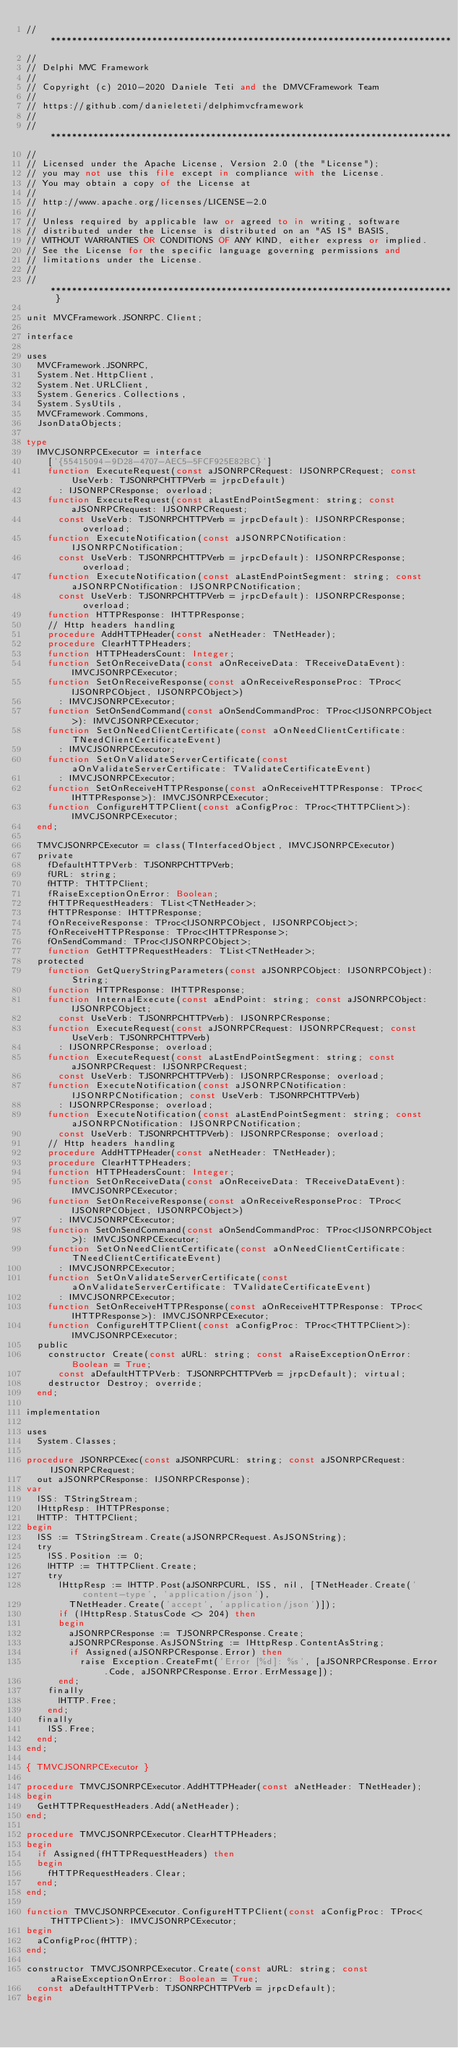Convert code to text. <code><loc_0><loc_0><loc_500><loc_500><_Pascal_>// ***************************************************************************
//
// Delphi MVC Framework
//
// Copyright (c) 2010-2020 Daniele Teti and the DMVCFramework Team
//
// https://github.com/danieleteti/delphimvcframework
//
// ***************************************************************************
//
// Licensed under the Apache License, Version 2.0 (the "License");
// you may not use this file except in compliance with the License.
// You may obtain a copy of the License at
//
// http://www.apache.org/licenses/LICENSE-2.0
//
// Unless required by applicable law or agreed to in writing, software
// distributed under the License is distributed on an "AS IS" BASIS,
// WITHOUT WARRANTIES OR CONDITIONS OF ANY KIND, either express or implied.
// See the License for the specific language governing permissions and
// limitations under the License.
//
// *************************************************************************** }

unit MVCFramework.JSONRPC.Client;

interface

uses
  MVCFramework.JSONRPC,
  System.Net.HttpClient,
  System.Net.URLClient,
  System.Generics.Collections,
  System.SysUtils,
  MVCFramework.Commons,
  JsonDataObjects;

type
  IMVCJSONRPCExecutor = interface
    ['{55415094-9D28-4707-AEC5-5FCF925E82BC}']
    function ExecuteRequest(const aJSONRPCRequest: IJSONRPCRequest; const UseVerb: TJSONRPCHTTPVerb = jrpcDefault)
      : IJSONRPCResponse; overload;
    function ExecuteRequest(const aLastEndPointSegment: string; const aJSONRPCRequest: IJSONRPCRequest;
      const UseVerb: TJSONRPCHTTPVerb = jrpcDefault): IJSONRPCResponse; overload;
    function ExecuteNotification(const aJSONRPCNotification: IJSONRPCNotification;
      const UseVerb: TJSONRPCHTTPVerb = jrpcDefault): IJSONRPCResponse; overload;
    function ExecuteNotification(const aLastEndPointSegment: string; const aJSONRPCNotification: IJSONRPCNotification;
      const UseVerb: TJSONRPCHTTPVerb = jrpcDefault): IJSONRPCResponse; overload;
    function HTTPResponse: IHTTPResponse;
    // Http headers handling
    procedure AddHTTPHeader(const aNetHeader: TNetHeader);
    procedure ClearHTTPHeaders;
    function HTTPHeadersCount: Integer;
    function SetOnReceiveData(const aOnReceiveData: TReceiveDataEvent): IMVCJSONRPCExecutor;
    function SetOnReceiveResponse(const aOnReceiveResponseProc: TProc<IJSONRPCObject, IJSONRPCObject>)
      : IMVCJSONRPCExecutor;
    function SetOnSendCommand(const aOnSendCommandProc: TProc<IJSONRPCObject>): IMVCJSONRPCExecutor;
    function SetOnNeedClientCertificate(const aOnNeedClientCertificate: TNeedClientCertificateEvent)
      : IMVCJSONRPCExecutor;
    function SetOnValidateServerCertificate(const aOnValidateServerCertificate: TValidateCertificateEvent)
      : IMVCJSONRPCExecutor;
    function SetOnReceiveHTTPResponse(const aOnReceiveHTTPResponse: TProc<IHTTPResponse>): IMVCJSONRPCExecutor;
    function ConfigureHTTPClient(const aConfigProc: TProc<THTTPClient>): IMVCJSONRPCExecutor;
  end;

  TMVCJSONRPCExecutor = class(TInterfacedObject, IMVCJSONRPCExecutor)
  private
    fDefaultHTTPVerb: TJSONRPCHTTPVerb;
    fURL: string;
    fHTTP: THTTPClient;
    fRaiseExceptionOnError: Boolean;
    fHTTPRequestHeaders: TList<TNetHeader>;
    fHTTPResponse: IHTTPResponse;
    fOnReceiveResponse: TProc<IJSONRPCObject, IJSONRPCObject>;
    fOnReceiveHTTPResponse: TProc<IHTTPResponse>;
    fOnSendCommand: TProc<IJSONRPCObject>;
    function GetHTTPRequestHeaders: TList<TNetHeader>;
  protected
    function GetQueryStringParameters(const aJSONRPCObject: IJSONRPCObject): String;
    function HTTPResponse: IHTTPResponse;
    function InternalExecute(const aEndPoint: string; const aJSONRPCObject: IJSONRPCObject;
      const UseVerb: TJSONRPCHTTPVerb): IJSONRPCResponse;
    function ExecuteRequest(const aJSONRPCRequest: IJSONRPCRequest; const UseVerb: TJSONRPCHTTPVerb)
      : IJSONRPCResponse; overload;
    function ExecuteRequest(const aLastEndPointSegment: string; const aJSONRPCRequest: IJSONRPCRequest;
      const UseVerb: TJSONRPCHTTPVerb): IJSONRPCResponse; overload;
    function ExecuteNotification(const aJSONRPCNotification: IJSONRPCNotification; const UseVerb: TJSONRPCHTTPVerb)
      : IJSONRPCResponse; overload;
    function ExecuteNotification(const aLastEndPointSegment: string; const aJSONRPCNotification: IJSONRPCNotification;
      const UseVerb: TJSONRPCHTTPVerb): IJSONRPCResponse; overload;
    // Http headers handling
    procedure AddHTTPHeader(const aNetHeader: TNetHeader);
    procedure ClearHTTPHeaders;
    function HTTPHeadersCount: Integer;
    function SetOnReceiveData(const aOnReceiveData: TReceiveDataEvent): IMVCJSONRPCExecutor;
    function SetOnReceiveResponse(const aOnReceiveResponseProc: TProc<IJSONRPCObject, IJSONRPCObject>)
      : IMVCJSONRPCExecutor;
    function SetOnSendCommand(const aOnSendCommandProc: TProc<IJSONRPCObject>): IMVCJSONRPCExecutor;
    function SetOnNeedClientCertificate(const aOnNeedClientCertificate: TNeedClientCertificateEvent)
      : IMVCJSONRPCExecutor;
    function SetOnValidateServerCertificate(const aOnValidateServerCertificate: TValidateCertificateEvent)
      : IMVCJSONRPCExecutor;
    function SetOnReceiveHTTPResponse(const aOnReceiveHTTPResponse: TProc<IHTTPResponse>): IMVCJSONRPCExecutor;
    function ConfigureHTTPClient(const aConfigProc: TProc<THTTPClient>): IMVCJSONRPCExecutor;
  public
    constructor Create(const aURL: string; const aRaiseExceptionOnError: Boolean = True;
      const aDefaultHTTPVerb: TJSONRPCHTTPVerb = jrpcDefault); virtual;
    destructor Destroy; override;
  end;

implementation

uses
  System.Classes;

procedure JSONRPCExec(const aJSONRPCURL: string; const aJSONRPCRequest: IJSONRPCRequest;
  out aJSONRPCResponse: IJSONRPCResponse);
var
  lSS: TStringStream;
  lHttpResp: IHTTPResponse;
  lHTTP: THTTPClient;
begin
  lSS := TStringStream.Create(aJSONRPCRequest.AsJSONString);
  try
    lSS.Position := 0;
    lHTTP := THTTPClient.Create;
    try
      lHttpResp := lHTTP.Post(aJSONRPCURL, lSS, nil, [TNetHeader.Create('content-type', 'application/json'),
        TNetHeader.Create('accept', 'application/json')]);
      if (lHttpResp.StatusCode <> 204) then
      begin
        aJSONRPCResponse := TJSONRPCResponse.Create;
        aJSONRPCResponse.AsJSONString := lHttpResp.ContentAsString;
        if Assigned(aJSONRPCResponse.Error) then
          raise Exception.CreateFmt('Error [%d]: %s', [aJSONRPCResponse.Error.Code, aJSONRPCResponse.Error.ErrMessage]);
      end;
    finally
      lHTTP.Free;
    end;
  finally
    lSS.Free;
  end;
end;

{ TMVCJSONRPCExecutor }

procedure TMVCJSONRPCExecutor.AddHTTPHeader(const aNetHeader: TNetHeader);
begin
  GetHTTPRequestHeaders.Add(aNetHeader);
end;

procedure TMVCJSONRPCExecutor.ClearHTTPHeaders;
begin
  if Assigned(fHTTPRequestHeaders) then
  begin
    fHTTPRequestHeaders.Clear;
  end;
end;

function TMVCJSONRPCExecutor.ConfigureHTTPClient(const aConfigProc: TProc<THTTPClient>): IMVCJSONRPCExecutor;
begin
  aConfigProc(fHTTP);
end;

constructor TMVCJSONRPCExecutor.Create(const aURL: string; const aRaiseExceptionOnError: Boolean = True;
  const aDefaultHTTPVerb: TJSONRPCHTTPVerb = jrpcDefault);
begin</code> 